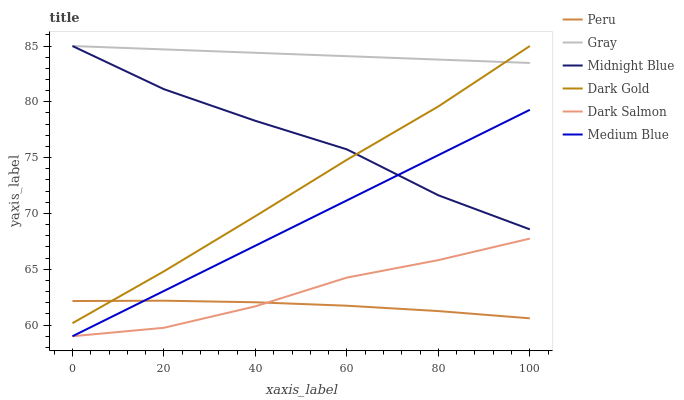Does Peru have the minimum area under the curve?
Answer yes or no. Yes. Does Gray have the maximum area under the curve?
Answer yes or no. Yes. Does Midnight Blue have the minimum area under the curve?
Answer yes or no. No. Does Midnight Blue have the maximum area under the curve?
Answer yes or no. No. Is Gray the smoothest?
Answer yes or no. Yes. Is Midnight Blue the roughest?
Answer yes or no. Yes. Is Dark Gold the smoothest?
Answer yes or no. No. Is Dark Gold the roughest?
Answer yes or no. No. Does Medium Blue have the lowest value?
Answer yes or no. Yes. Does Midnight Blue have the lowest value?
Answer yes or no. No. Does Dark Gold have the highest value?
Answer yes or no. Yes. Does Medium Blue have the highest value?
Answer yes or no. No. Is Peru less than Midnight Blue?
Answer yes or no. Yes. Is Midnight Blue greater than Dark Salmon?
Answer yes or no. Yes. Does Dark Gold intersect Gray?
Answer yes or no. Yes. Is Dark Gold less than Gray?
Answer yes or no. No. Is Dark Gold greater than Gray?
Answer yes or no. No. Does Peru intersect Midnight Blue?
Answer yes or no. No. 